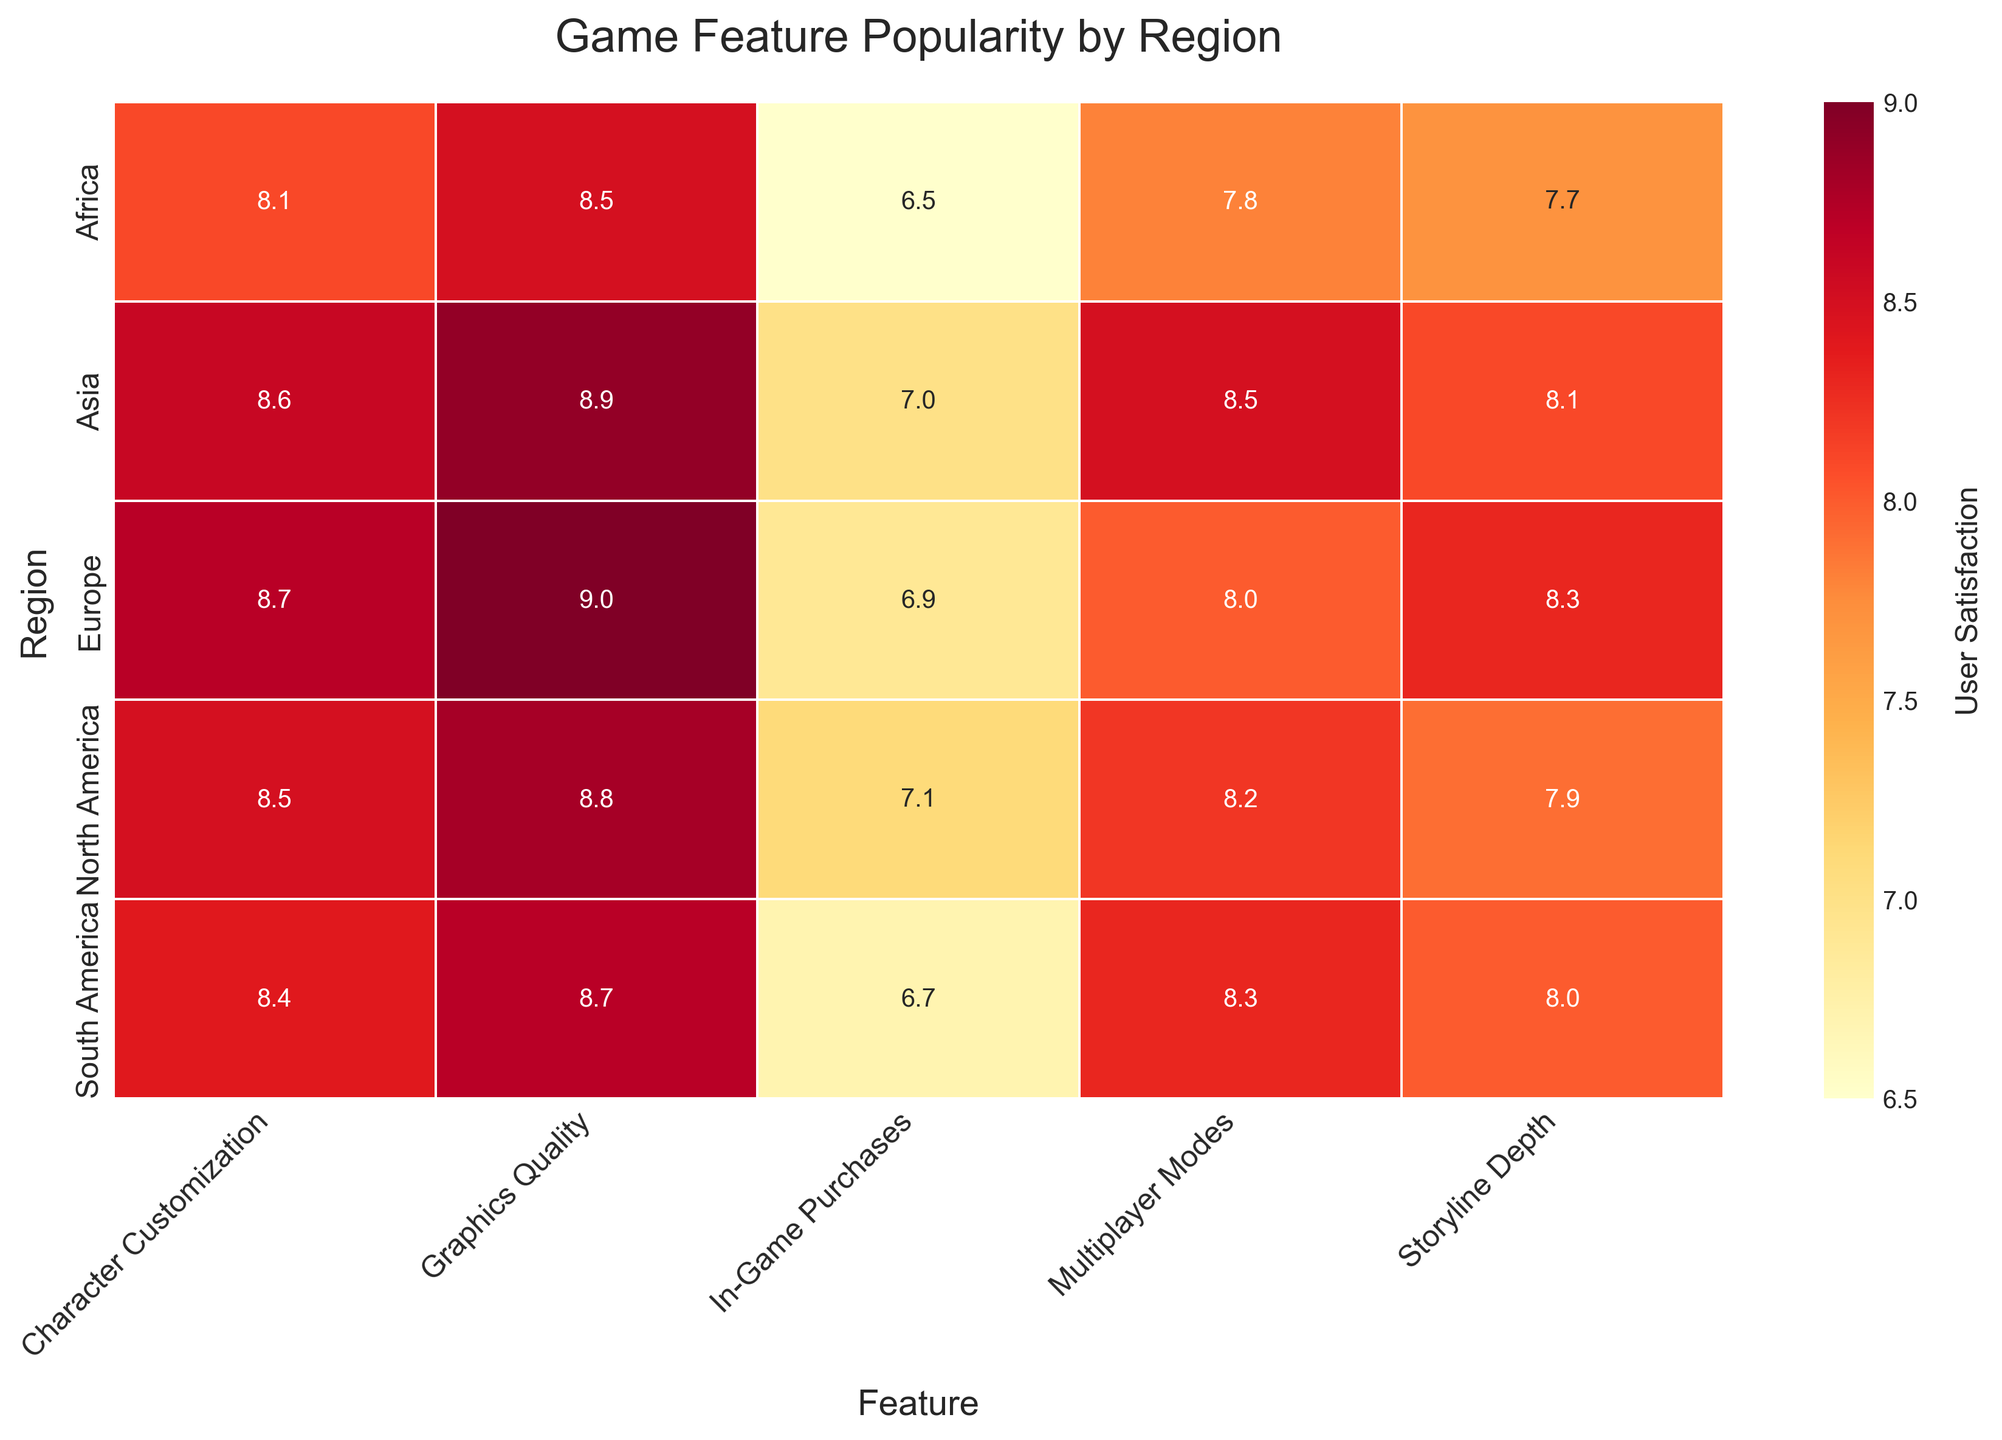What is the title of the heatmap? To find the title, look at the top of the figure.
Answer: Game Feature Popularity by Region Which region has the highest user satisfaction for Graphics Quality? Locate the column for Graphics Quality and identify the highest value among the regions.
Answer: Europe What is the user satisfaction score for Storyline Depth in South America? Look in the South America row under the Storyline Depth column.
Answer: 8.0 How do the user satisfaction scores for Multiplayer Modes compare between North America and Asia? Compare the values in the Multiplayer Modes column for North America and Asia.
Answer: Asia has a higher score (8.5) compared to North America (8.2) Which game feature has the lowest user satisfaction in Africa? Find the minimum value in the Africa row and identify the corresponding feature.
Answer: In-Game Purchases Calculate the average user satisfaction for Character Customization across all regions. Sum the user satisfaction scores for Character Customization from all regions and divide by the number of regions (5). (8.5 + 8.7 + 8.6 + 8.4 + 8.1)/5 = 42.3/5 = 8.46
Answer: 8.46 Which region has the lowest overall user satisfaction for game features? Sum the user satisfaction scores for each region and identify the region with the lowest total.
Answer: Africa Compare the user satisfaction scores of In-Game Purchases between Europe and South America. Which region prefers this feature more? Compare the scores for In-Game Purchases between Europe and South America (6.9 vs 6.7).
Answer: Europe Identify the feature with the maximum variability in user satisfaction across regions. Examine the range (difference between maximum and minimum scores) for each feature and find the one with the largest range.
Answer: In-Game Purchases Which region shows a slightly higher preference for Storyline Depth than Multiplayer Modes? Look for a region where the score for Storyline Depth is just above the score for Multiplayer Modes.
Answer: Europe 